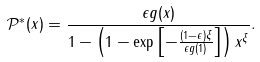<formula> <loc_0><loc_0><loc_500><loc_500>\mathcal { P } ^ { * } ( x ) = \frac { \epsilon g ( x ) } { 1 - \left ( 1 - \exp \left [ - \frac { ( 1 - \epsilon ) \xi } { \epsilon g ( 1 ) } \right ] \right ) x ^ { \xi } } .</formula> 